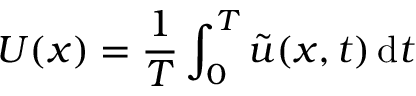Convert formula to latex. <formula><loc_0><loc_0><loc_500><loc_500>U ( x ) = \frac { 1 } { T } \int _ { 0 } ^ { T } \tilde { u } ( x , t ) \, d t</formula> 